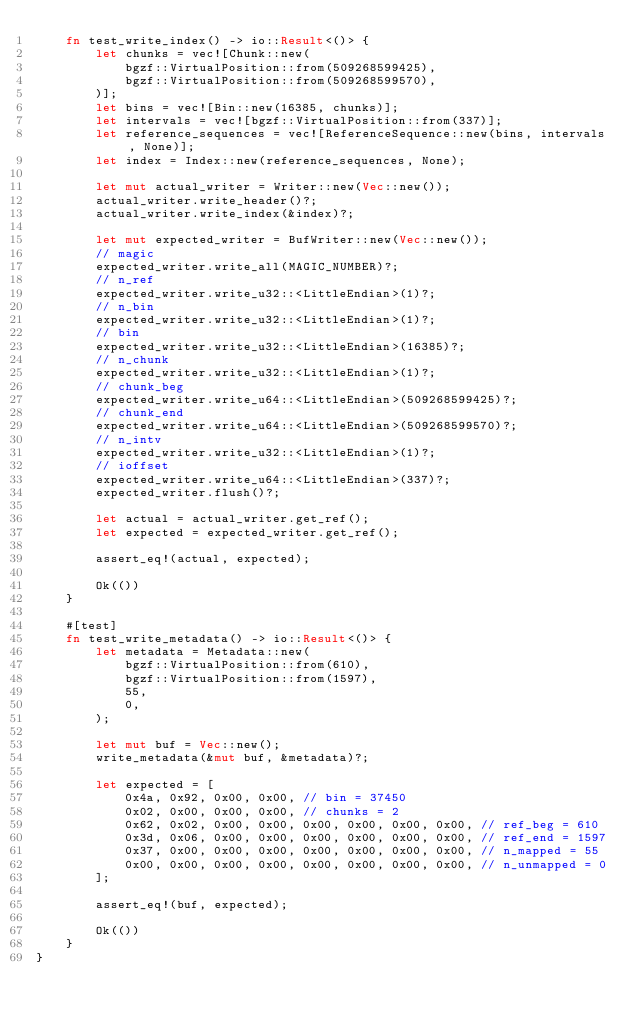<code> <loc_0><loc_0><loc_500><loc_500><_Rust_>    fn test_write_index() -> io::Result<()> {
        let chunks = vec![Chunk::new(
            bgzf::VirtualPosition::from(509268599425),
            bgzf::VirtualPosition::from(509268599570),
        )];
        let bins = vec![Bin::new(16385, chunks)];
        let intervals = vec![bgzf::VirtualPosition::from(337)];
        let reference_sequences = vec![ReferenceSequence::new(bins, intervals, None)];
        let index = Index::new(reference_sequences, None);

        let mut actual_writer = Writer::new(Vec::new());
        actual_writer.write_header()?;
        actual_writer.write_index(&index)?;

        let mut expected_writer = BufWriter::new(Vec::new());
        // magic
        expected_writer.write_all(MAGIC_NUMBER)?;
        // n_ref
        expected_writer.write_u32::<LittleEndian>(1)?;
        // n_bin
        expected_writer.write_u32::<LittleEndian>(1)?;
        // bin
        expected_writer.write_u32::<LittleEndian>(16385)?;
        // n_chunk
        expected_writer.write_u32::<LittleEndian>(1)?;
        // chunk_beg
        expected_writer.write_u64::<LittleEndian>(509268599425)?;
        // chunk_end
        expected_writer.write_u64::<LittleEndian>(509268599570)?;
        // n_intv
        expected_writer.write_u32::<LittleEndian>(1)?;
        // ioffset
        expected_writer.write_u64::<LittleEndian>(337)?;
        expected_writer.flush()?;

        let actual = actual_writer.get_ref();
        let expected = expected_writer.get_ref();

        assert_eq!(actual, expected);

        Ok(())
    }

    #[test]
    fn test_write_metadata() -> io::Result<()> {
        let metadata = Metadata::new(
            bgzf::VirtualPosition::from(610),
            bgzf::VirtualPosition::from(1597),
            55,
            0,
        );

        let mut buf = Vec::new();
        write_metadata(&mut buf, &metadata)?;

        let expected = [
            0x4a, 0x92, 0x00, 0x00, // bin = 37450
            0x02, 0x00, 0x00, 0x00, // chunks = 2
            0x62, 0x02, 0x00, 0x00, 0x00, 0x00, 0x00, 0x00, // ref_beg = 610
            0x3d, 0x06, 0x00, 0x00, 0x00, 0x00, 0x00, 0x00, // ref_end = 1597
            0x37, 0x00, 0x00, 0x00, 0x00, 0x00, 0x00, 0x00, // n_mapped = 55
            0x00, 0x00, 0x00, 0x00, 0x00, 0x00, 0x00, 0x00, // n_unmapped = 0
        ];

        assert_eq!(buf, expected);

        Ok(())
    }
}
</code> 